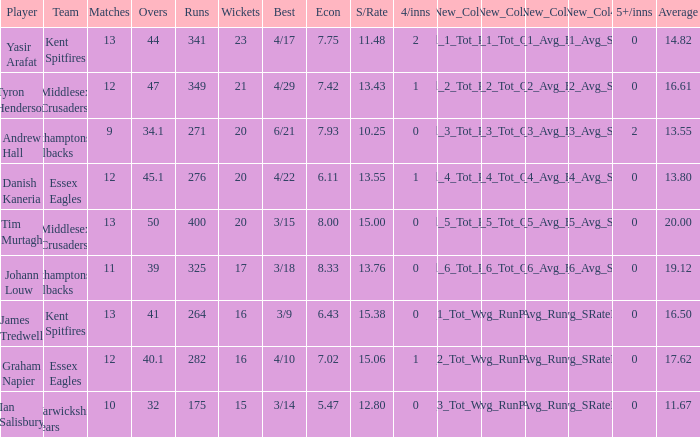Name the most 4/inns 2.0. 